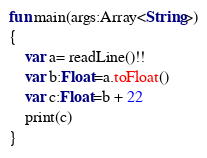Convert code to text. <code><loc_0><loc_0><loc_500><loc_500><_Kotlin_>fun main(args:Array<String>)
{
    var a= readLine()!!
    var b:Float=a.toFloat()
    var c:Float=b + 22
    print(c)
}
</code> 